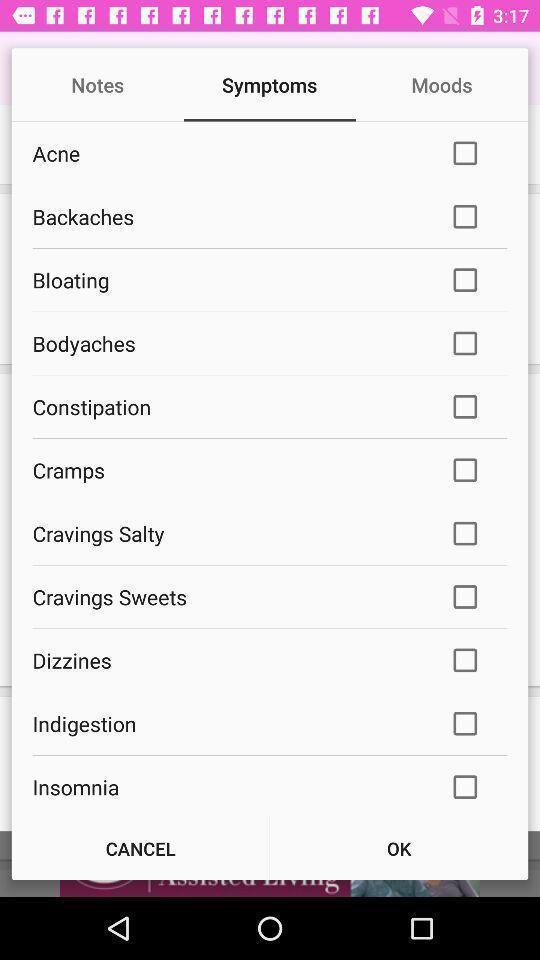Provide a detailed account of this screenshot. Symptoms checklist in a health app. 